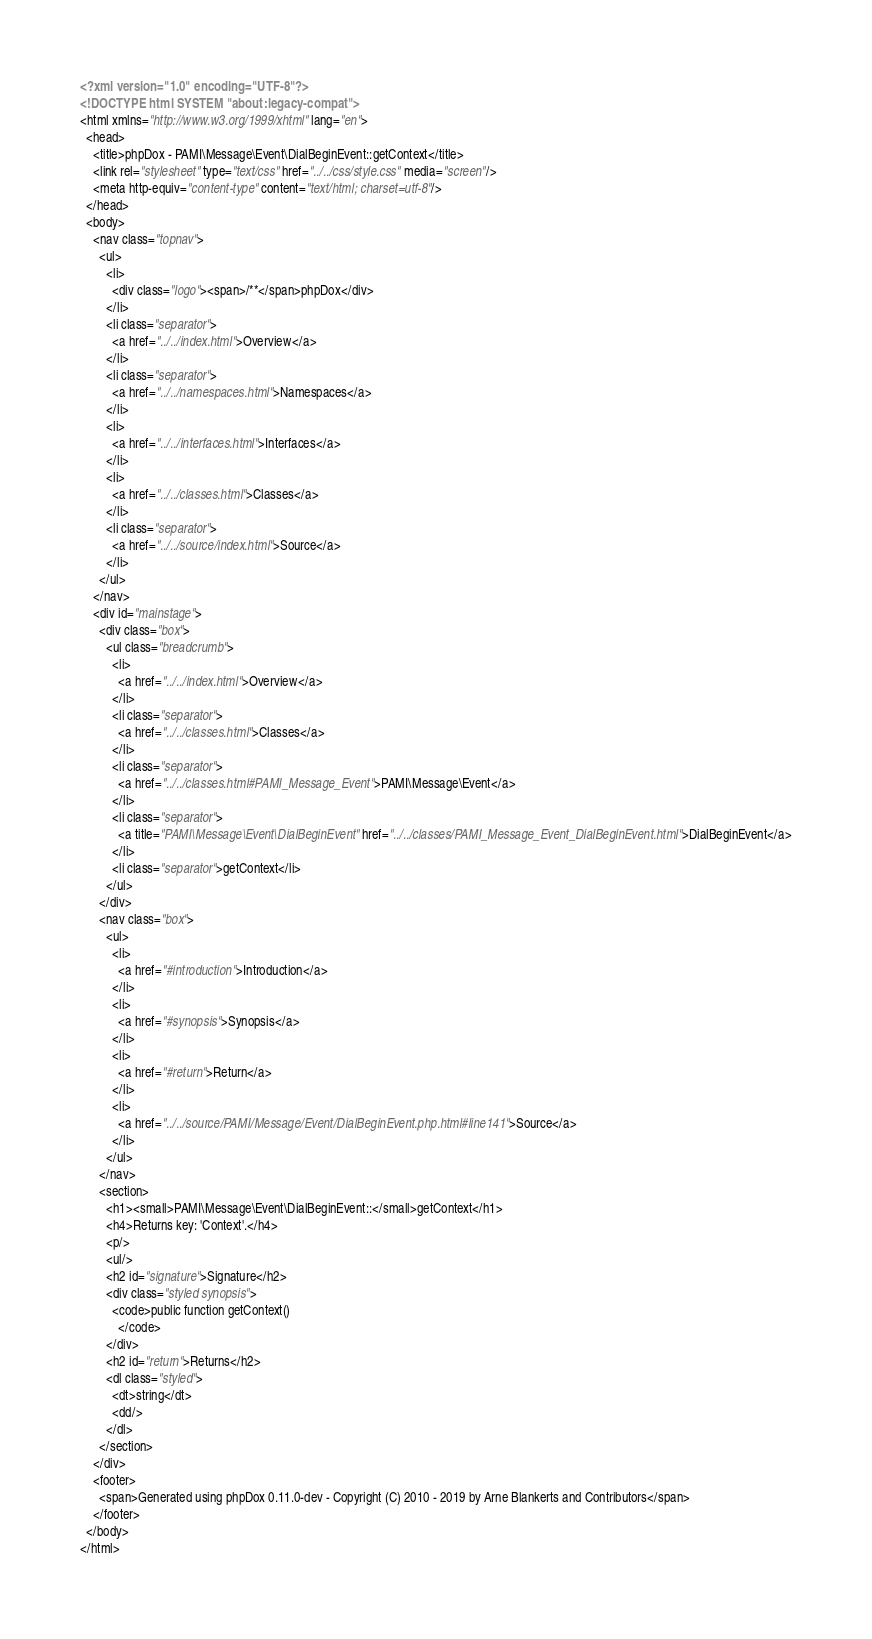Convert code to text. <code><loc_0><loc_0><loc_500><loc_500><_HTML_><?xml version="1.0" encoding="UTF-8"?>
<!DOCTYPE html SYSTEM "about:legacy-compat">
<html xmlns="http://www.w3.org/1999/xhtml" lang="en">
  <head>
    <title>phpDox - PAMI\Message\Event\DialBeginEvent::getContext</title>
    <link rel="stylesheet" type="text/css" href="../../css/style.css" media="screen"/>
    <meta http-equiv="content-type" content="text/html; charset=utf-8"/>
  </head>
  <body>
    <nav class="topnav">
      <ul>
        <li>
          <div class="logo"><span>/**</span>phpDox</div>
        </li>
        <li class="separator">
          <a href="../../index.html">Overview</a>
        </li>
        <li class="separator">
          <a href="../../namespaces.html">Namespaces</a>
        </li>
        <li>
          <a href="../../interfaces.html">Interfaces</a>
        </li>
        <li>
          <a href="../../classes.html">Classes</a>
        </li>
        <li class="separator">
          <a href="../../source/index.html">Source</a>
        </li>
      </ul>
    </nav>
    <div id="mainstage">
      <div class="box">
        <ul class="breadcrumb">
          <li>
            <a href="../../index.html">Overview</a>
          </li>
          <li class="separator">
            <a href="../../classes.html">Classes</a>
          </li>
          <li class="separator">
            <a href="../../classes.html#PAMI_Message_Event">PAMI\Message\Event</a>
          </li>
          <li class="separator">
            <a title="PAMI\Message\Event\DialBeginEvent" href="../../classes/PAMI_Message_Event_DialBeginEvent.html">DialBeginEvent</a>
          </li>
          <li class="separator">getContext</li>
        </ul>
      </div>
      <nav class="box">
        <ul>
          <li>
            <a href="#introduction">Introduction</a>
          </li>
          <li>
            <a href="#synopsis">Synopsis</a>
          </li>
          <li>
            <a href="#return">Return</a>
          </li>
          <li>
            <a href="../../source/PAMI/Message/Event/DialBeginEvent.php.html#line141">Source</a>
          </li>
        </ul>
      </nav>
      <section>
        <h1><small>PAMI\Message\Event\DialBeginEvent::</small>getContext</h1>
        <h4>Returns key: 'Context'.</h4>
        <p/>
        <ul/>
        <h2 id="signature">Signature</h2>
        <div class="styled synopsis">
          <code>public function getContext()
            </code>
        </div>
        <h2 id="return">Returns</h2>
        <dl class="styled">
          <dt>string</dt>
          <dd/>
        </dl>
      </section>
    </div>
    <footer>
      <span>Generated using phpDox 0.11.0-dev - Copyright (C) 2010 - 2019 by Arne Blankerts and Contributors</span>
    </footer>
  </body>
</html>
</code> 